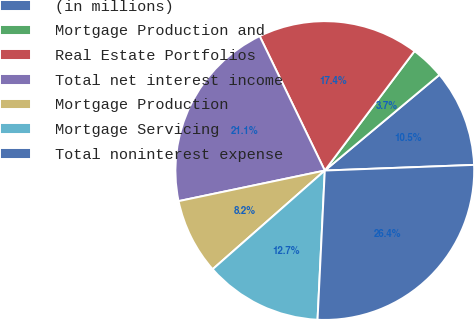<chart> <loc_0><loc_0><loc_500><loc_500><pie_chart><fcel>(in millions)<fcel>Mortgage Production and<fcel>Real Estate Portfolios<fcel>Total net interest income<fcel>Mortgage Production<fcel>Mortgage Servicing<fcel>Total noninterest expense<nl><fcel>10.47%<fcel>3.67%<fcel>17.43%<fcel>21.1%<fcel>8.2%<fcel>12.74%<fcel>26.37%<nl></chart> 